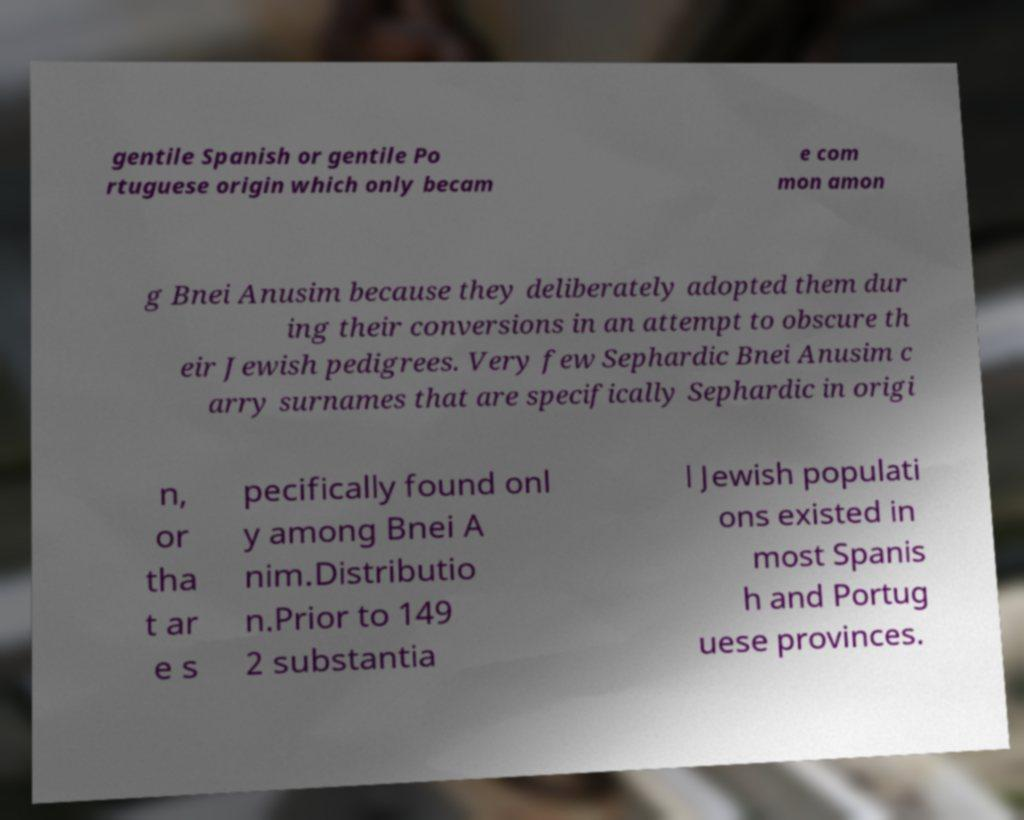What messages or text are displayed in this image? I need them in a readable, typed format. gentile Spanish or gentile Po rtuguese origin which only becam e com mon amon g Bnei Anusim because they deliberately adopted them dur ing their conversions in an attempt to obscure th eir Jewish pedigrees. Very few Sephardic Bnei Anusim c arry surnames that are specifically Sephardic in origi n, or tha t ar e s pecifically found onl y among Bnei A nim.Distributio n.Prior to 149 2 substantia l Jewish populati ons existed in most Spanis h and Portug uese provinces. 